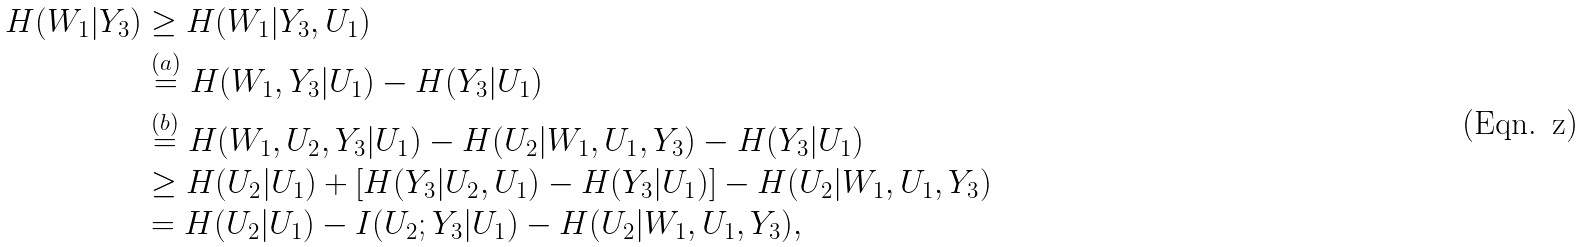<formula> <loc_0><loc_0><loc_500><loc_500>H ( W _ { 1 } | Y _ { 3 } ) & \geq H ( W _ { 1 } | Y _ { 3 } , U _ { 1 } ) \\ & \stackrel { ( a ) } { = } H ( W _ { 1 } , Y _ { 3 } | U _ { 1 } ) - H ( Y _ { 3 } | U _ { 1 } ) \\ & \stackrel { ( b ) } { = } H ( W _ { 1 } , U _ { 2 } , Y _ { 3 } | U _ { 1 } ) - H ( U _ { 2 } | W _ { 1 } , U _ { 1 } , Y _ { 3 } ) - H ( Y _ { 3 } | U _ { 1 } ) \\ & \geq H ( U _ { 2 } | U _ { 1 } ) + [ H ( Y _ { 3 } | U _ { 2 } , U _ { 1 } ) - H ( Y _ { 3 } | U _ { 1 } ) ] - H ( U _ { 2 } | W _ { 1 } , U _ { 1 } , Y _ { 3 } ) \\ & = H ( U _ { 2 } | U _ { 1 } ) - I ( U _ { 2 } ; Y _ { 3 } | U _ { 1 } ) - H ( U _ { 2 } | W _ { 1 } , U _ { 1 } , Y _ { 3 } ) ,</formula> 